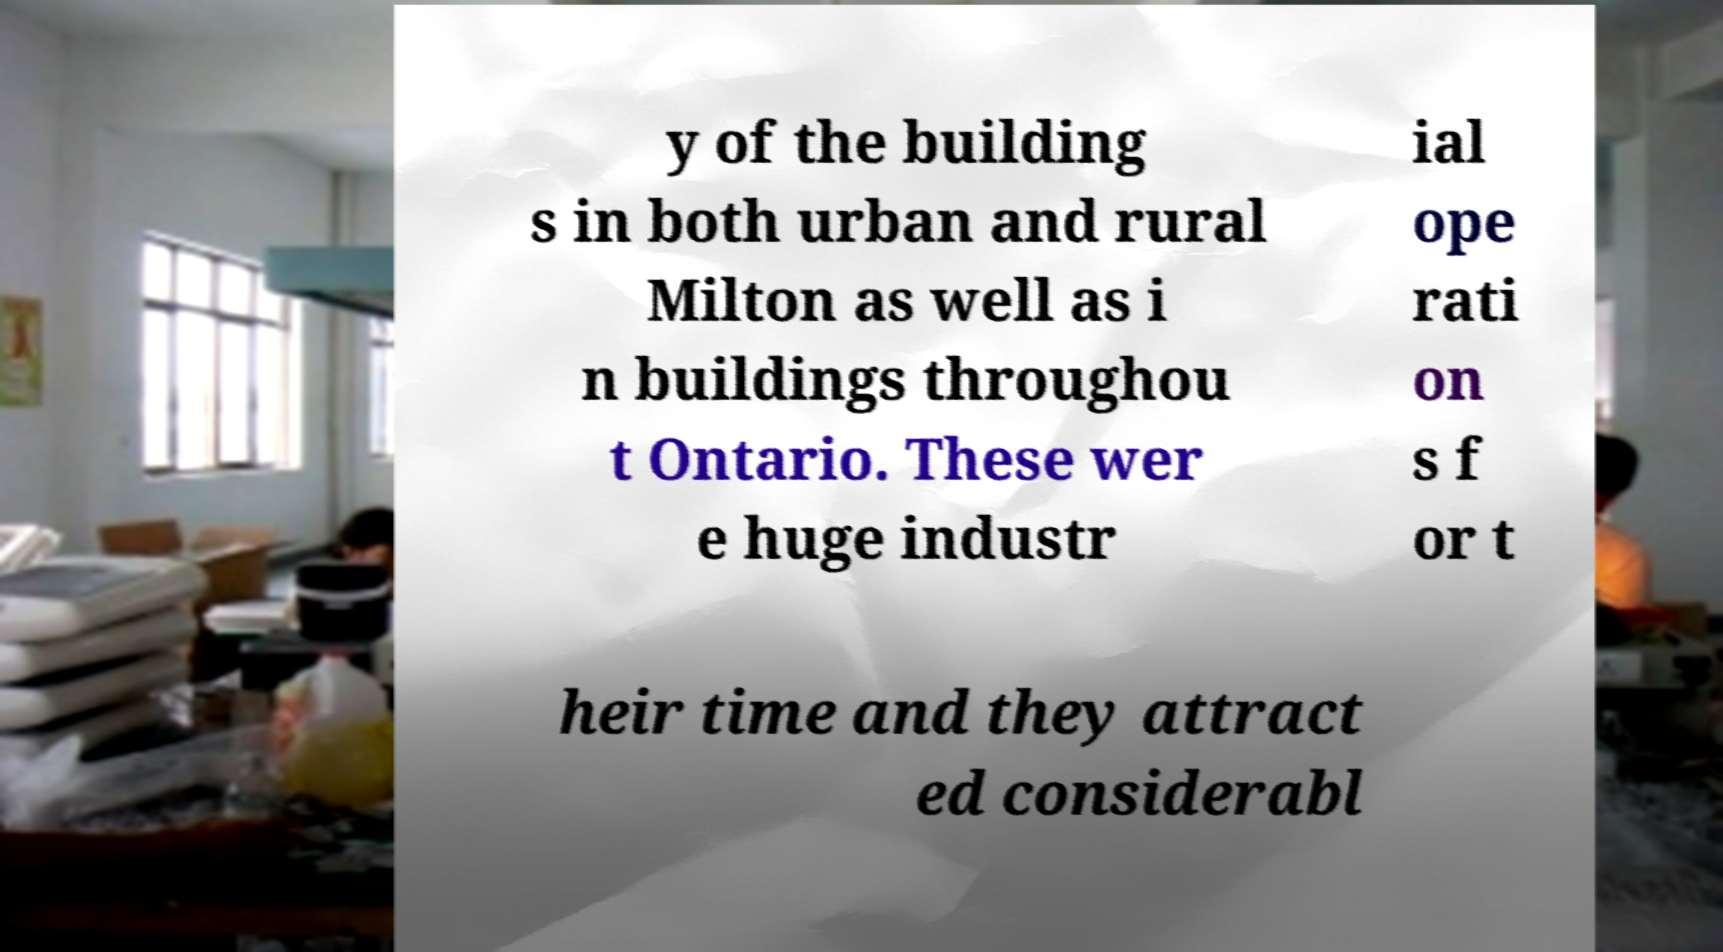There's text embedded in this image that I need extracted. Can you transcribe it verbatim? y of the building s in both urban and rural Milton as well as i n buildings throughou t Ontario. These wer e huge industr ial ope rati on s f or t heir time and they attract ed considerabl 